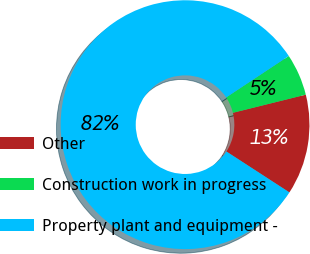Convert chart to OTSL. <chart><loc_0><loc_0><loc_500><loc_500><pie_chart><fcel>Other<fcel>Construction work in progress<fcel>Property plant and equipment -<nl><fcel>13.04%<fcel>5.43%<fcel>81.53%<nl></chart> 